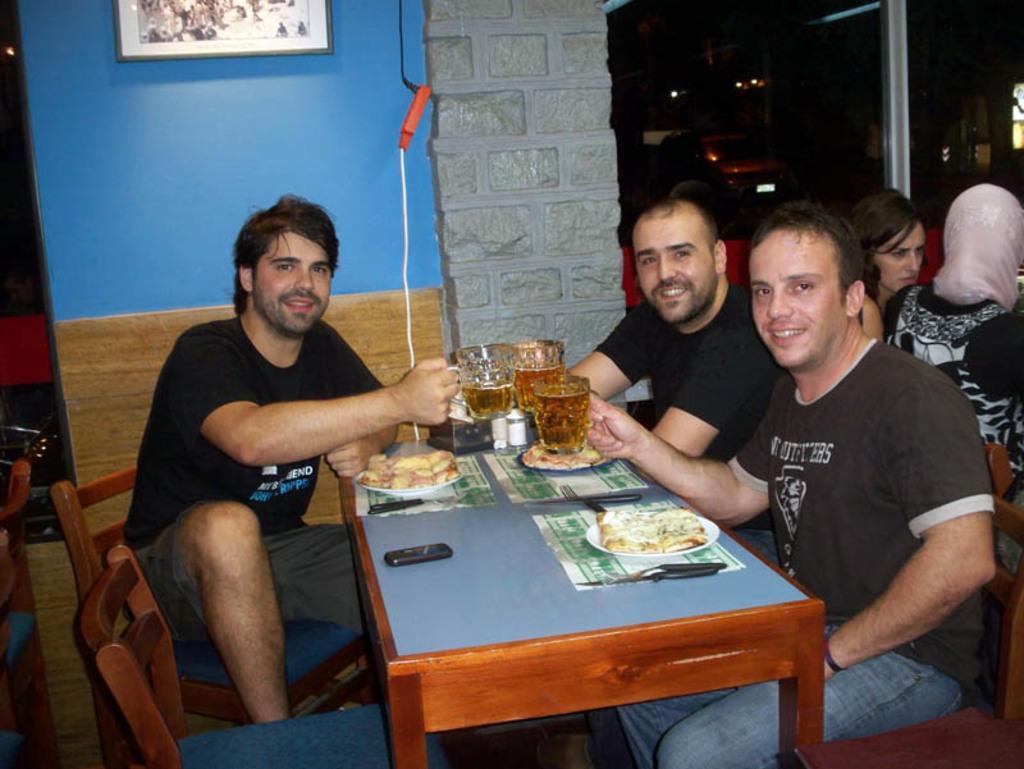Could you give a brief overview of what you see in this image? There are three person sitting on chairs. They are holding glasses. In front of them there are tables. On the table there are plates, food items, mobile and knives. In the background there is a wall and photo frame. 